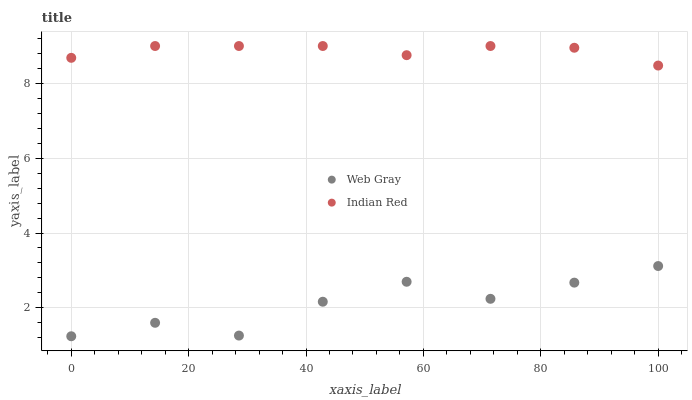Does Web Gray have the minimum area under the curve?
Answer yes or no. Yes. Does Indian Red have the maximum area under the curve?
Answer yes or no. Yes. Does Indian Red have the minimum area under the curve?
Answer yes or no. No. Is Indian Red the smoothest?
Answer yes or no. Yes. Is Web Gray the roughest?
Answer yes or no. Yes. Is Indian Red the roughest?
Answer yes or no. No. Does Web Gray have the lowest value?
Answer yes or no. Yes. Does Indian Red have the lowest value?
Answer yes or no. No. Does Indian Red have the highest value?
Answer yes or no. Yes. Is Web Gray less than Indian Red?
Answer yes or no. Yes. Is Indian Red greater than Web Gray?
Answer yes or no. Yes. Does Web Gray intersect Indian Red?
Answer yes or no. No. 